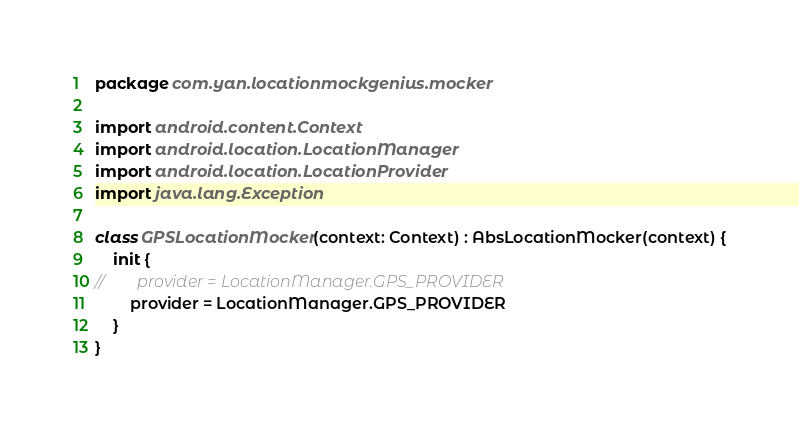Convert code to text. <code><loc_0><loc_0><loc_500><loc_500><_Kotlin_>package com.yan.locationmockgenius.mocker

import android.content.Context
import android.location.LocationManager
import android.location.LocationProvider
import java.lang.Exception

class GPSLocationMocker(context: Context) : AbsLocationMocker(context) {
    init {
//        provider = LocationManager.GPS_PROVIDER
        provider = LocationManager.GPS_PROVIDER
    }
}</code> 